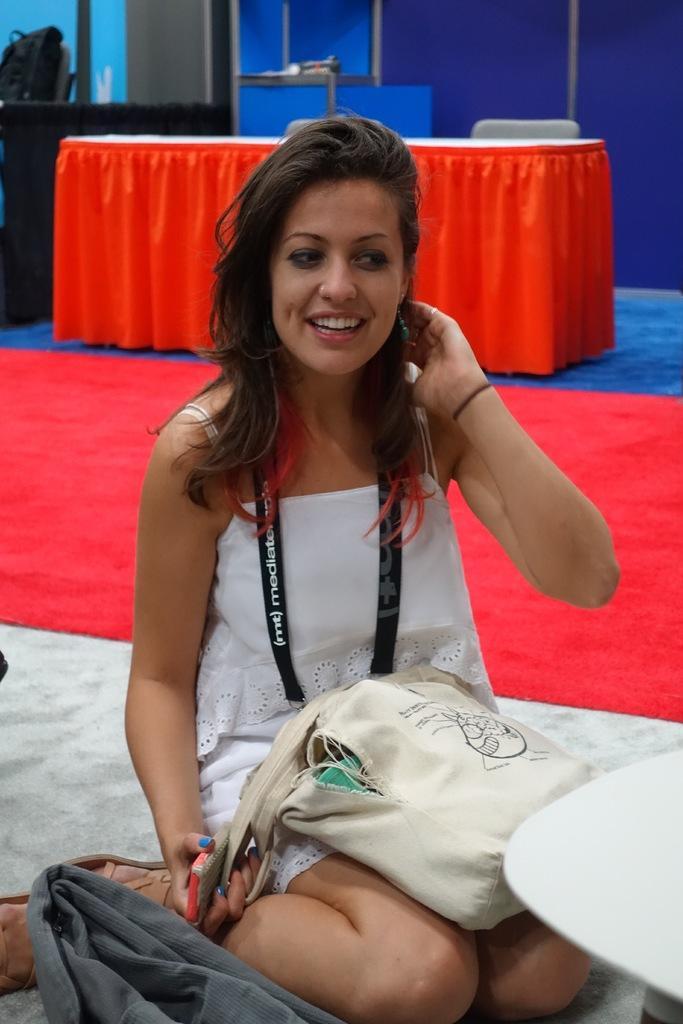Could you give a brief overview of what you see in this image? In the middle of this image, there is a woman in a white color dress, smiling, wearing a badge, holding a mobile with a hand, sitting and keeping a handbag on her lap. Beside her, there is a cloth and a white color object. In the background, there is a red color curtain on the floor, there is a table which is covered with an orange color cloth. Beside this table, there is a chair, there is a wall and other objects. 